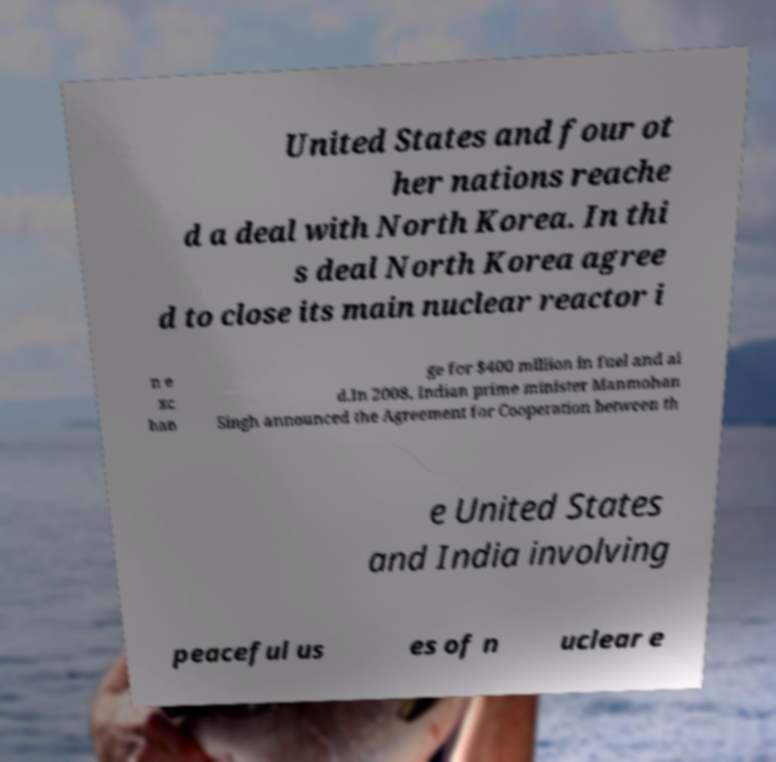Can you read and provide the text displayed in the image?This photo seems to have some interesting text. Can you extract and type it out for me? United States and four ot her nations reache d a deal with North Korea. In thi s deal North Korea agree d to close its main nuclear reactor i n e xc han ge for $400 million in fuel and ai d.In 2008, Indian prime minister Manmohan Singh announced the Agreement for Cooperation between th e United States and India involving peaceful us es of n uclear e 